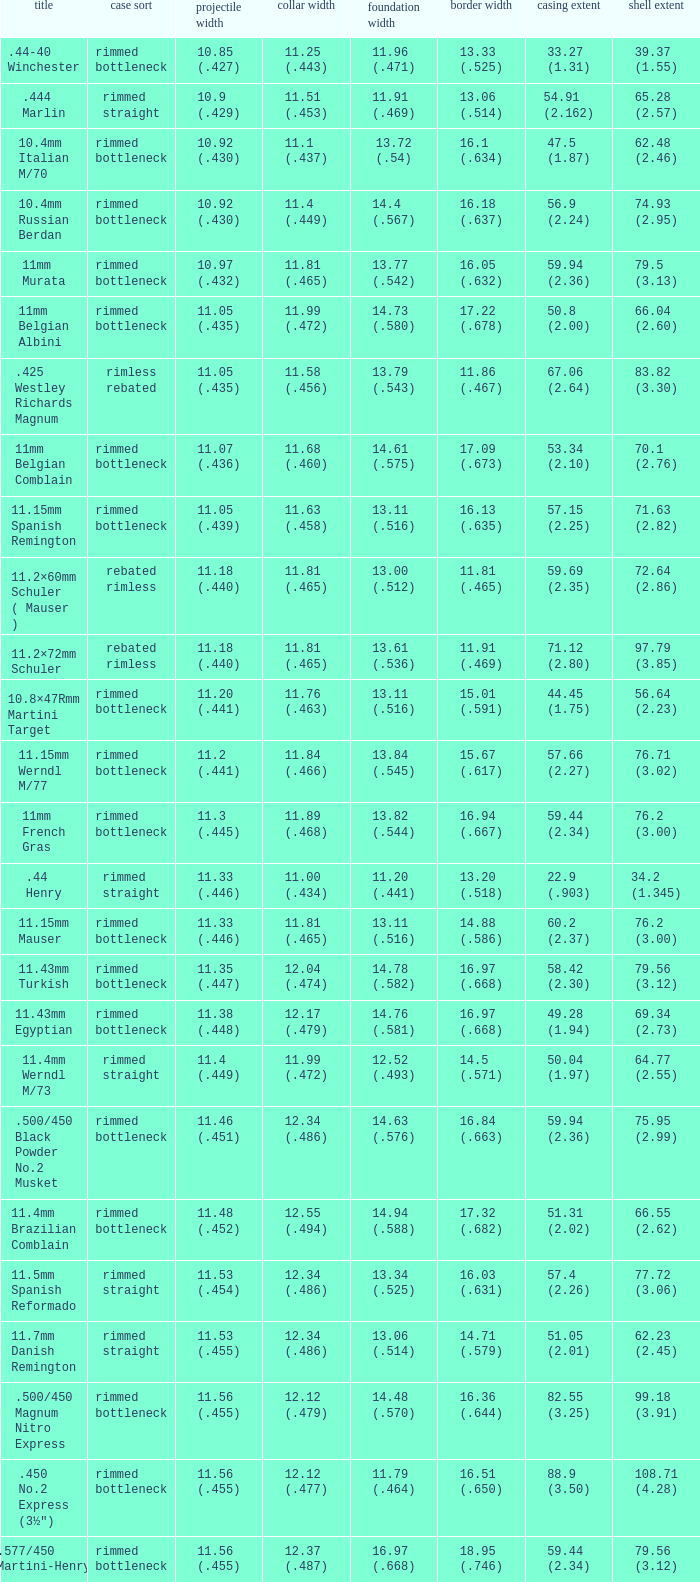Which Rim diameter has a Neck diameter of 11.84 (.466)? 15.67 (.617). 